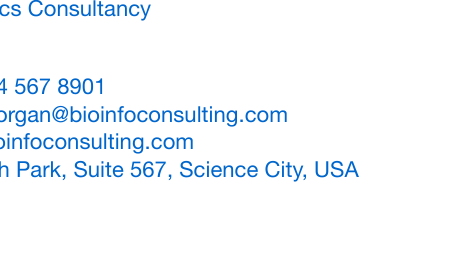What is the name of the bioinformatics consultant? The name listed in the document is Dr. Alex Morgan.
Answer: Dr. Alex Morgan What is the primary job title of Dr. Alex Morgan? The title stated on the card is Bioinformatics Scientist & Consultant.
Answer: Bioinformatics Scientist & Consultant How many services are offered? The document lists three specific services provided by the consultant.
Answer: 3 What is one of the services offered? The document notes that Genomic Data Analysis is one of the listed services.
Answer: Genomic Data Analysis What is the contact phone number? The phone number provided in the document is +1 234 567 8901.
Answer: +1 234 567 8901 Where is Dr. Alex Morgan's office located? The address stated in the card is 1234 Research Park, Suite 567, Science City, USA.
Answer: 1234 Research Park, Suite 567, Science City, USA What color is the main theme of the business card? The primary color used in the design is RGB(0,102,204).
Answer: RGB(0,102,204) What type of document is this? The document is specifically a business card designed to promote research services.
Answer: Business card What element is included in the background design? The background design features a small plot or graph as part of its aesthetic.
Answer: Plot or graph 